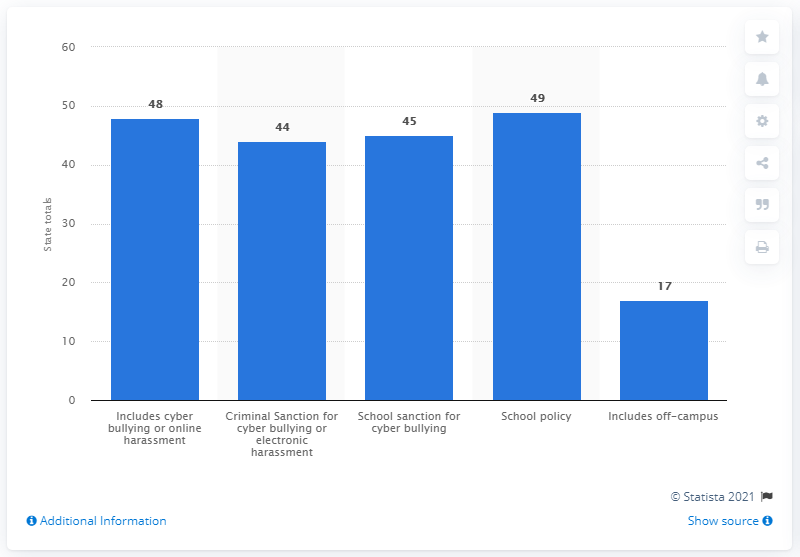Outline some significant characteristics in this image. As of November 2018, 48 states had electronic harassment laws that explicitly included cyberbullying. Forty-four states have included criminal sanctions in their cyberbullying laws. 